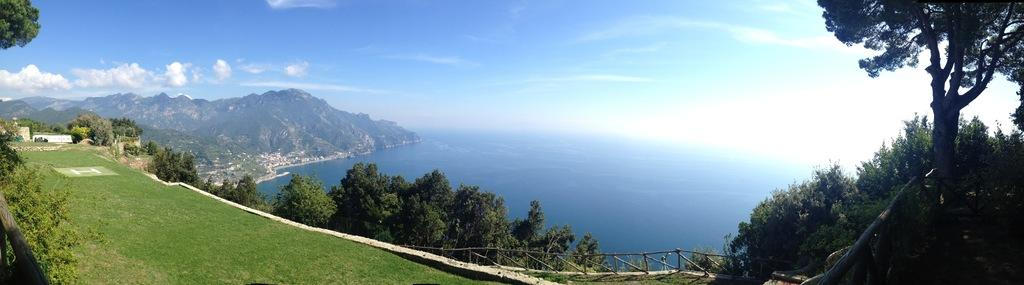What type of vegetation is present in the image? There are trees in the image. What type of ground cover is visible in the image? There is grass in the image. What type of barrier is present in the image? There is a fence in the image. What natural feature is visible in the image? There is water visible in the image. What type of large landforms are present in the image? There are mountains in the image. What part of the natural environment is visible in the image? The sky is visible in the image. How does the water cause trouble in the image? There is no indication in the image that the water is causing any trouble. What type of sand can be seen on the beach in the image? There is no beach or sand present in the image. 